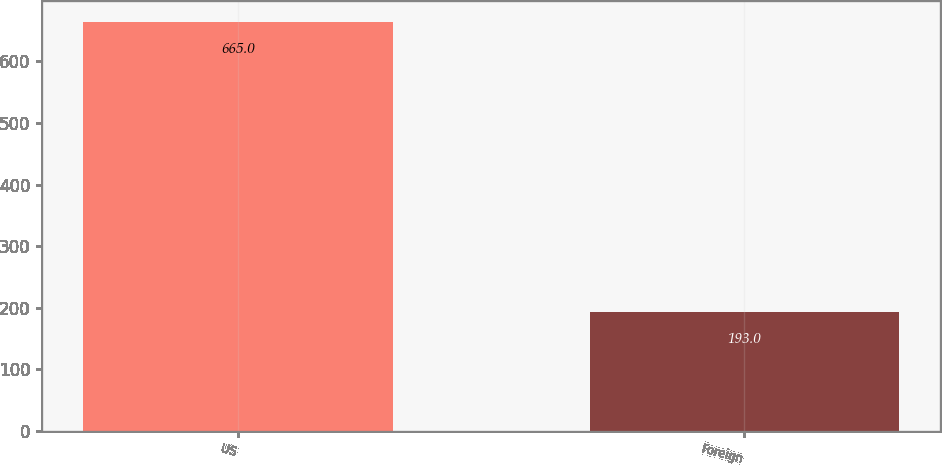Convert chart. <chart><loc_0><loc_0><loc_500><loc_500><bar_chart><fcel>US<fcel>Foreign<nl><fcel>665<fcel>193<nl></chart> 